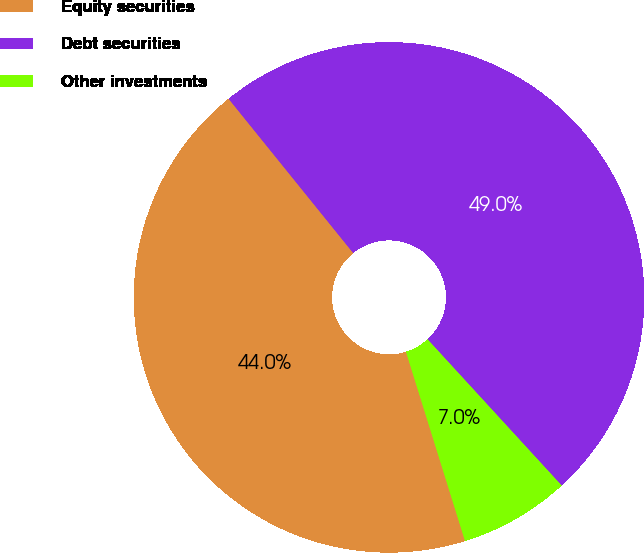Convert chart to OTSL. <chart><loc_0><loc_0><loc_500><loc_500><pie_chart><fcel>Equity securities<fcel>Debt securities<fcel>Other investments<nl><fcel>44.0%<fcel>49.0%<fcel>7.0%<nl></chart> 